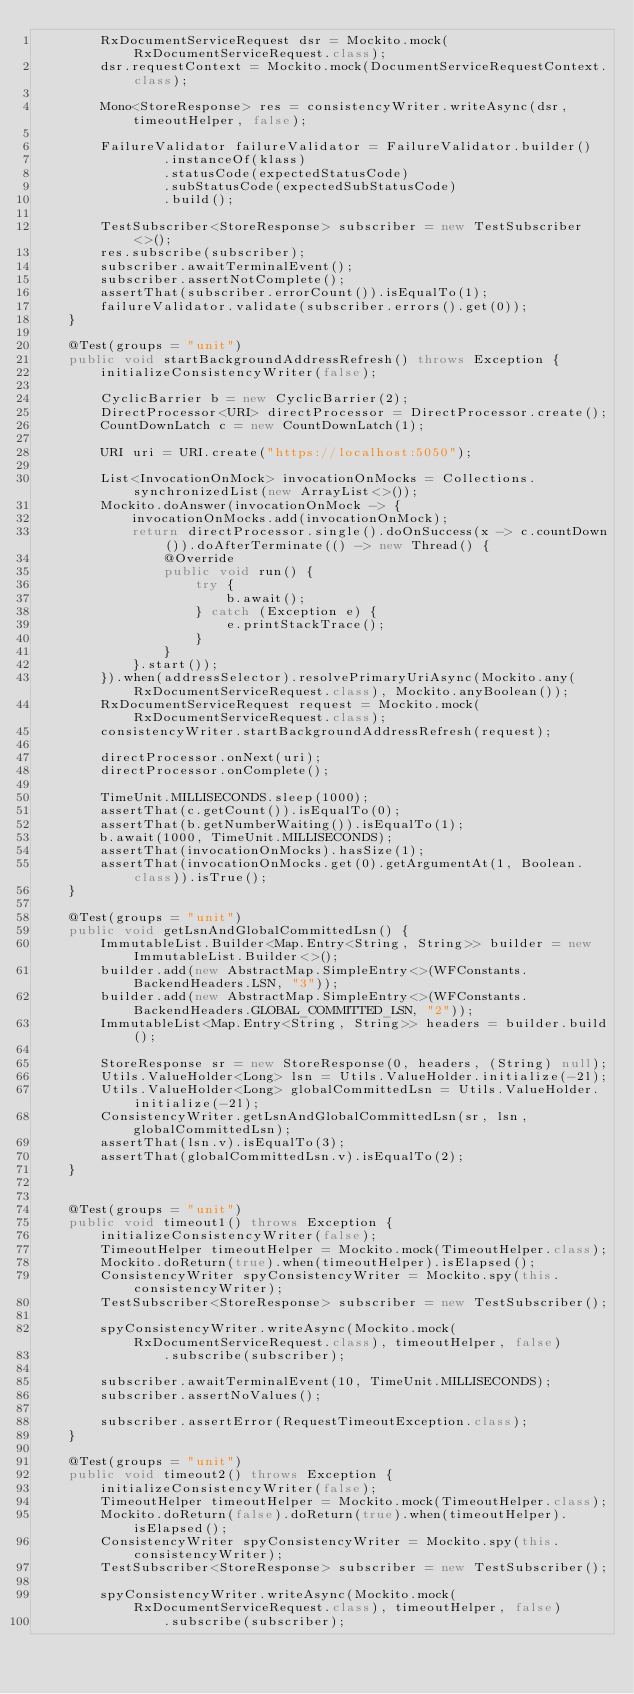<code> <loc_0><loc_0><loc_500><loc_500><_Java_>        RxDocumentServiceRequest dsr = Mockito.mock(RxDocumentServiceRequest.class);
        dsr.requestContext = Mockito.mock(DocumentServiceRequestContext.class);

        Mono<StoreResponse> res = consistencyWriter.writeAsync(dsr, timeoutHelper, false);

        FailureValidator failureValidator = FailureValidator.builder()
                .instanceOf(klass)
                .statusCode(expectedStatusCode)
                .subStatusCode(expectedSubStatusCode)
                .build();

        TestSubscriber<StoreResponse> subscriber = new TestSubscriber<>();
        res.subscribe(subscriber);
        subscriber.awaitTerminalEvent();
        subscriber.assertNotComplete();
        assertThat(subscriber.errorCount()).isEqualTo(1);
        failureValidator.validate(subscriber.errors().get(0));
    }

    @Test(groups = "unit")
    public void startBackgroundAddressRefresh() throws Exception {
        initializeConsistencyWriter(false);

        CyclicBarrier b = new CyclicBarrier(2);
        DirectProcessor<URI> directProcessor = DirectProcessor.create();
        CountDownLatch c = new CountDownLatch(1);

        URI uri = URI.create("https://localhost:5050");

        List<InvocationOnMock> invocationOnMocks = Collections.synchronizedList(new ArrayList<>());
        Mockito.doAnswer(invocationOnMock -> {
            invocationOnMocks.add(invocationOnMock);
            return directProcessor.single().doOnSuccess(x -> c.countDown()).doAfterTerminate(() -> new Thread() {
                @Override
                public void run() {
                    try {
                        b.await();
                    } catch (Exception e) {
                        e.printStackTrace();
                    }
                }
            }.start());
        }).when(addressSelector).resolvePrimaryUriAsync(Mockito.any(RxDocumentServiceRequest.class), Mockito.anyBoolean());
        RxDocumentServiceRequest request = Mockito.mock(RxDocumentServiceRequest.class);
        consistencyWriter.startBackgroundAddressRefresh(request);

        directProcessor.onNext(uri);
        directProcessor.onComplete();

        TimeUnit.MILLISECONDS.sleep(1000);
        assertThat(c.getCount()).isEqualTo(0);
        assertThat(b.getNumberWaiting()).isEqualTo(1);
        b.await(1000, TimeUnit.MILLISECONDS);
        assertThat(invocationOnMocks).hasSize(1);
        assertThat(invocationOnMocks.get(0).getArgumentAt(1, Boolean.class)).isTrue();
    }

    @Test(groups = "unit")
    public void getLsnAndGlobalCommittedLsn() {
        ImmutableList.Builder<Map.Entry<String, String>> builder = new ImmutableList.Builder<>();
        builder.add(new AbstractMap.SimpleEntry<>(WFConstants.BackendHeaders.LSN, "3"));
        builder.add(new AbstractMap.SimpleEntry<>(WFConstants.BackendHeaders.GLOBAL_COMMITTED_LSN, "2"));
        ImmutableList<Map.Entry<String, String>> headers = builder.build();

        StoreResponse sr = new StoreResponse(0, headers, (String) null);
        Utils.ValueHolder<Long> lsn = Utils.ValueHolder.initialize(-2l);
        Utils.ValueHolder<Long> globalCommittedLsn = Utils.ValueHolder.initialize(-2l);
        ConsistencyWriter.getLsnAndGlobalCommittedLsn(sr, lsn, globalCommittedLsn);
        assertThat(lsn.v).isEqualTo(3);
        assertThat(globalCommittedLsn.v).isEqualTo(2);
    }


    @Test(groups = "unit")
    public void timeout1() throws Exception {
        initializeConsistencyWriter(false);
        TimeoutHelper timeoutHelper = Mockito.mock(TimeoutHelper.class);
        Mockito.doReturn(true).when(timeoutHelper).isElapsed();
        ConsistencyWriter spyConsistencyWriter = Mockito.spy(this.consistencyWriter);
        TestSubscriber<StoreResponse> subscriber = new TestSubscriber();

        spyConsistencyWriter.writeAsync(Mockito.mock(RxDocumentServiceRequest.class), timeoutHelper, false)
                .subscribe(subscriber);

        subscriber.awaitTerminalEvent(10, TimeUnit.MILLISECONDS);
        subscriber.assertNoValues();

        subscriber.assertError(RequestTimeoutException.class);
    }

    @Test(groups = "unit")
    public void timeout2() throws Exception {
        initializeConsistencyWriter(false);
        TimeoutHelper timeoutHelper = Mockito.mock(TimeoutHelper.class);
        Mockito.doReturn(false).doReturn(true).when(timeoutHelper).isElapsed();
        ConsistencyWriter spyConsistencyWriter = Mockito.spy(this.consistencyWriter);
        TestSubscriber<StoreResponse> subscriber = new TestSubscriber();

        spyConsistencyWriter.writeAsync(Mockito.mock(RxDocumentServiceRequest.class), timeoutHelper, false)
                .subscribe(subscriber);
</code> 